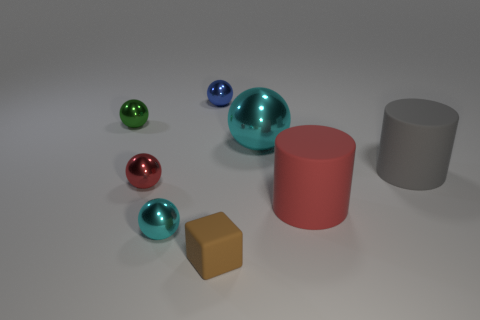Is the size of the matte block the same as the cyan metallic thing that is behind the gray rubber thing?
Make the answer very short. No. There is a thing in front of the cyan metallic thing in front of the big object that is in front of the gray thing; what is its material?
Offer a very short reply. Rubber. How many objects are either large cyan metal balls or small green shiny objects?
Keep it short and to the point. 2. There is a shiny object that is on the right side of the small brown object; is it the same color as the shiny ball in front of the red rubber cylinder?
Offer a very short reply. Yes. The brown object that is the same size as the red metallic object is what shape?
Keep it short and to the point. Cube. What number of objects are either metallic balls that are right of the small brown rubber cube or cyan objects to the left of the brown object?
Give a very brief answer. 2. Is the number of brown things less than the number of green matte spheres?
Offer a terse response. No. There is another cylinder that is the same size as the red cylinder; what is its material?
Provide a short and direct response. Rubber. Do the cyan thing that is to the left of the big cyan shiny ball and the matte thing that is to the left of the big ball have the same size?
Provide a short and direct response. Yes. Is there a brown block made of the same material as the big ball?
Give a very brief answer. No. 